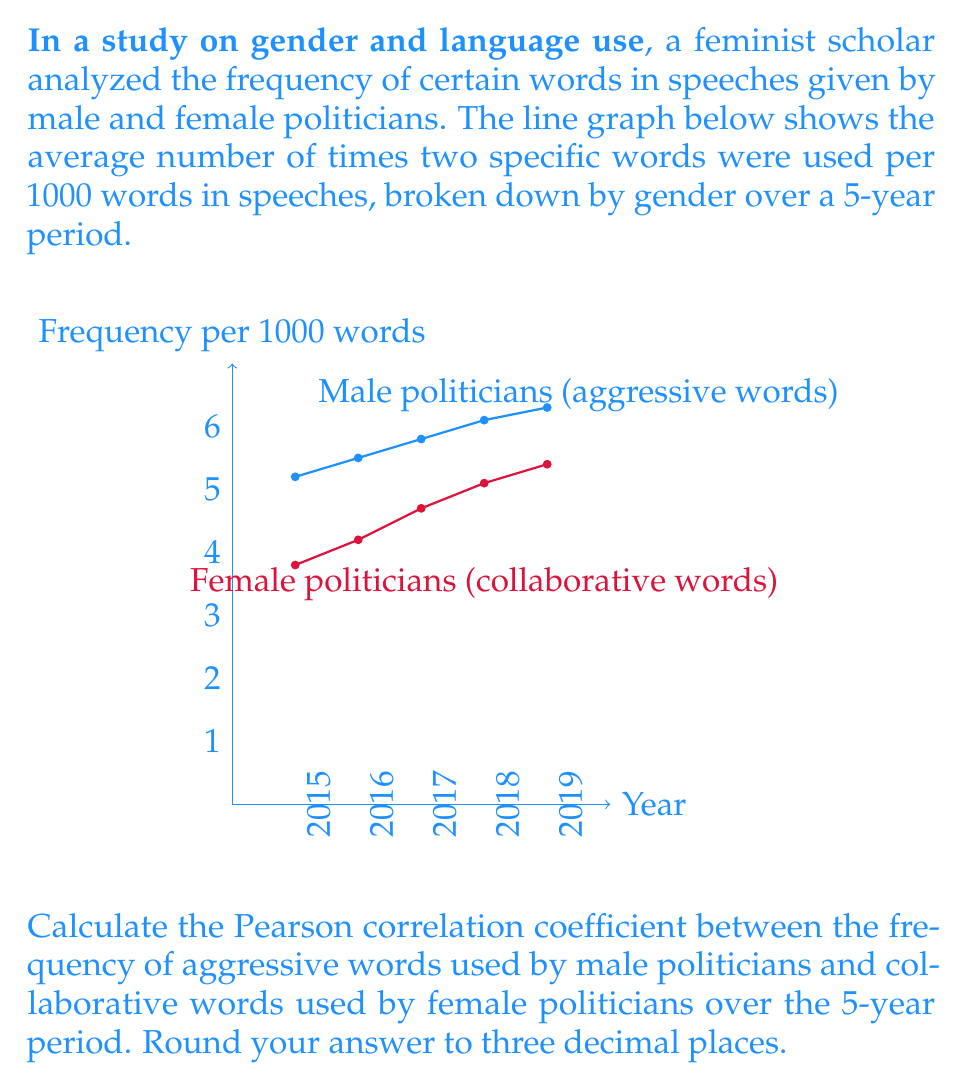What is the answer to this math problem? To calculate the Pearson correlation coefficient, we'll follow these steps:

1. Let $x$ represent the frequency of aggressive words used by male politicians and $y$ represent the frequency of collaborative words used by female politicians.

2. Calculate the means:
   $\bar{x} = \frac{5.2 + 5.5 + 5.8 + 6.1 + 6.3}{5} = 5.78$
   $\bar{y} = \frac{3.8 + 4.2 + 4.7 + 5.1 + 5.4}{5} = 4.64$

3. Calculate the differences from the mean:
   $x - \bar{x}: -0.58, -0.28, 0.02, 0.32, 0.52$
   $y - \bar{y}: -0.84, -0.44, 0.06, 0.46, 0.76$

4. Calculate the products of these differences:
   $(x - \bar{x})(y - \bar{y}): 0.4872, 0.1232, 0.0012, 0.1472, 0.3952$

5. Sum these products:
   $\sum(x - \bar{x})(y - \bar{y}) = 1.154$

6. Calculate the squared differences:
   $(x - \bar{x})^2: 0.3364, 0.0784, 0.0004, 0.1024, 0.2704$
   $(y - \bar{y})^2: 0.7056, 0.1936, 0.0036, 0.2116, 0.5776$

7. Sum the squared differences:
   $\sum(x - \bar{x})^2 = 0.788$
   $\sum(y - \bar{y})^2 = 1.692$

8. Apply the Pearson correlation coefficient formula:
   $$r = \frac{\sum(x - \bar{x})(y - \bar{y})}{\sqrt{\sum(x - \bar{x})^2 \sum(y - \bar{y})^2}}$$
   
   $$r = \frac{1.154}{\sqrt{0.788 * 1.692}} = \frac{1.154}{\sqrt{1.33317}} = \frac{1.154}{1.15464} = 0.9994$$

9. Round to three decimal places: 0.999
Answer: 0.999 